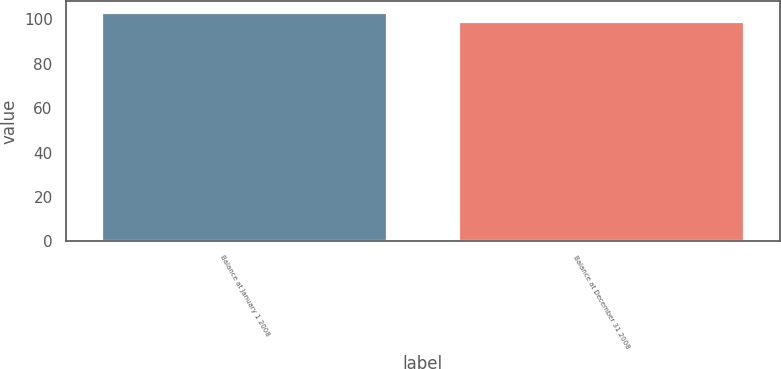<chart> <loc_0><loc_0><loc_500><loc_500><bar_chart><fcel>Balance at January 1 2008<fcel>Balance at December 31 2008<nl><fcel>103<fcel>99<nl></chart> 